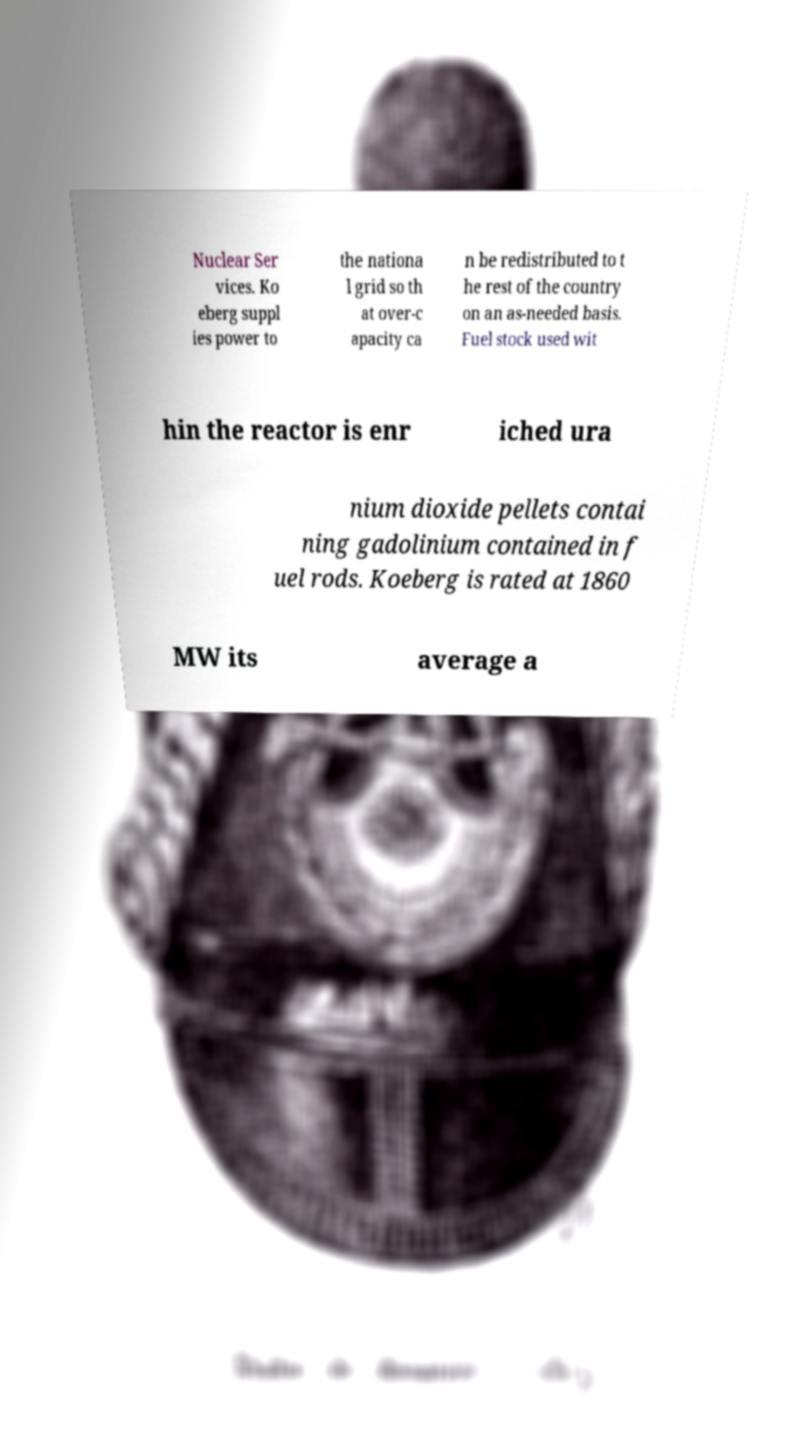Please read and relay the text visible in this image. What does it say? Nuclear Ser vices. Ko eberg suppl ies power to the nationa l grid so th at over-c apacity ca n be redistributed to t he rest of the country on an as-needed basis. Fuel stock used wit hin the reactor is enr iched ura nium dioxide pellets contai ning gadolinium contained in f uel rods. Koeberg is rated at 1860 MW its average a 